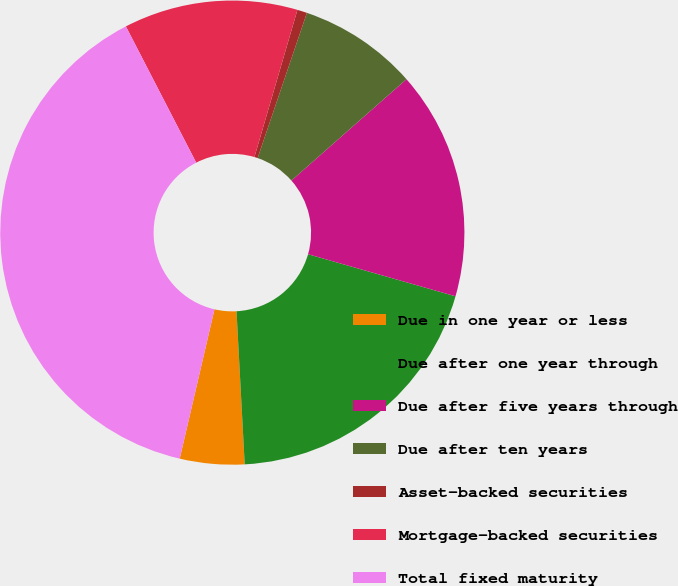Convert chart. <chart><loc_0><loc_0><loc_500><loc_500><pie_chart><fcel>Due in one year or less<fcel>Due after one year through<fcel>Due after five years through<fcel>Due after ten years<fcel>Asset-backed securities<fcel>Mortgage-backed securities<fcel>Total fixed maturity<nl><fcel>4.49%<fcel>19.73%<fcel>15.92%<fcel>8.3%<fcel>0.68%<fcel>12.11%<fcel>38.78%<nl></chart> 